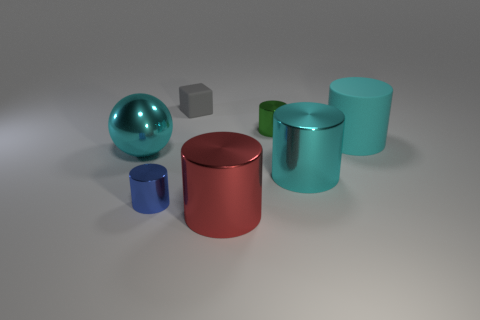What number of large cylinders have the same color as the rubber cube?
Ensure brevity in your answer.  0. Are there fewer big cyan metallic things on the left side of the large cyan rubber object than large rubber things that are left of the small gray block?
Offer a terse response. No. There is a object that is to the left of the blue shiny cylinder; how big is it?
Your answer should be very brief. Large. What size is the rubber cylinder that is the same color as the large sphere?
Keep it short and to the point. Large. Are there any large brown spheres that have the same material as the red thing?
Keep it short and to the point. No. Are the tiny block and the green object made of the same material?
Your answer should be compact. No. There is a cube that is the same size as the green thing; what color is it?
Your answer should be compact. Gray. How many other objects are there of the same shape as the large red metal object?
Your answer should be compact. 4. Is the size of the green shiny cylinder the same as the cyan object on the left side of the small matte object?
Keep it short and to the point. No. How many things are either gray objects or yellow rubber things?
Keep it short and to the point. 1. 